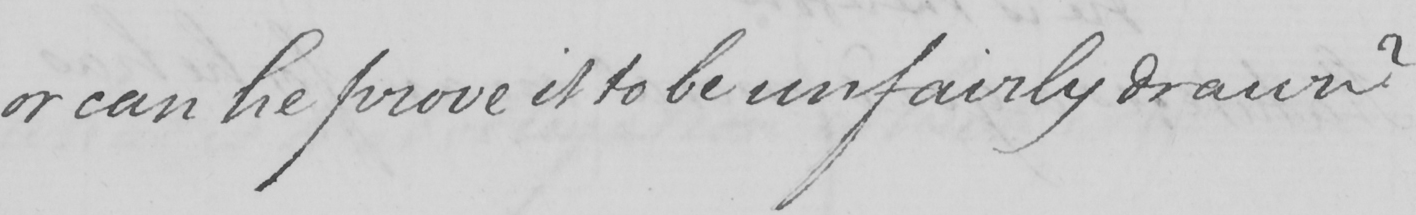Can you tell me what this handwritten text says? or can he prove it to be unfairly drawn ? 